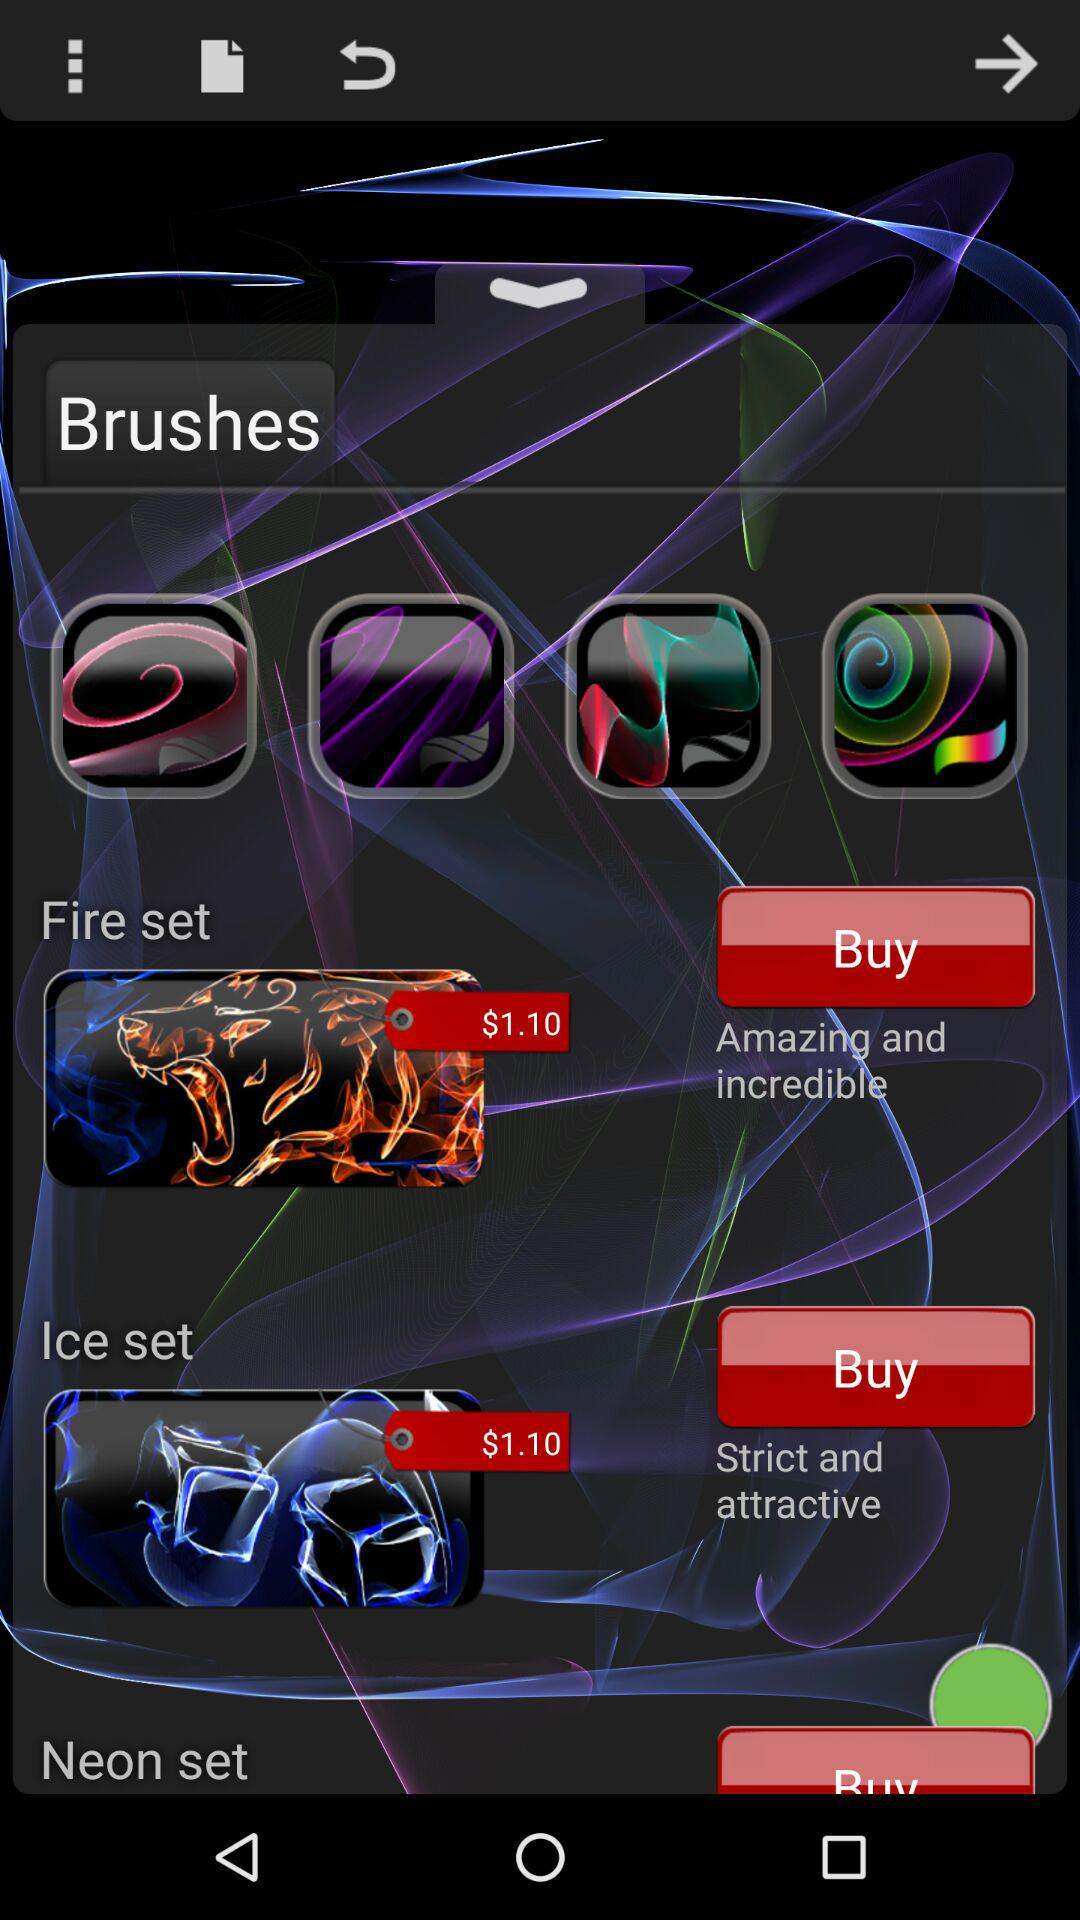Which brushes have amazing and incredible features? The brush with amazing and incredible features is "Fire set". 